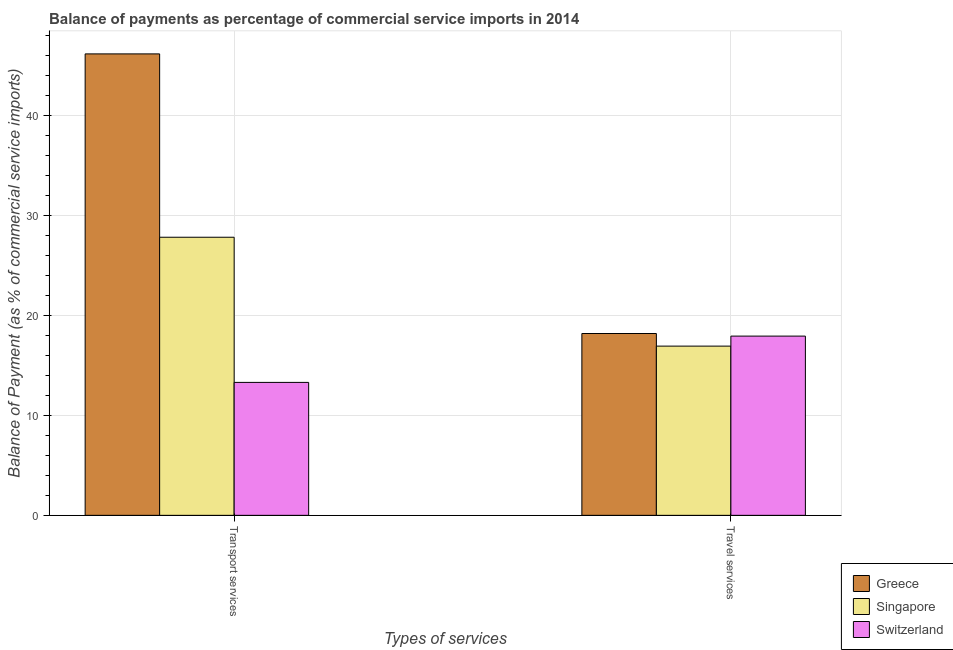How many different coloured bars are there?
Ensure brevity in your answer.  3. Are the number of bars on each tick of the X-axis equal?
Provide a short and direct response. Yes. How many bars are there on the 2nd tick from the left?
Offer a very short reply. 3. What is the label of the 2nd group of bars from the left?
Your answer should be compact. Travel services. What is the balance of payments of transport services in Singapore?
Keep it short and to the point. 27.83. Across all countries, what is the maximum balance of payments of transport services?
Provide a short and direct response. 46.17. Across all countries, what is the minimum balance of payments of travel services?
Ensure brevity in your answer.  16.93. In which country was the balance of payments of travel services maximum?
Keep it short and to the point. Greece. In which country was the balance of payments of travel services minimum?
Your response must be concise. Singapore. What is the total balance of payments of transport services in the graph?
Provide a succinct answer. 87.3. What is the difference between the balance of payments of travel services in Greece and that in Singapore?
Provide a short and direct response. 1.26. What is the difference between the balance of payments of travel services in Switzerland and the balance of payments of transport services in Greece?
Your answer should be very brief. -28.24. What is the average balance of payments of transport services per country?
Keep it short and to the point. 29.1. What is the difference between the balance of payments of transport services and balance of payments of travel services in Switzerland?
Your response must be concise. -4.63. What is the ratio of the balance of payments of travel services in Greece to that in Singapore?
Provide a short and direct response. 1.07. Is the balance of payments of transport services in Greece less than that in Switzerland?
Your response must be concise. No. What does the 2nd bar from the left in Transport services represents?
Your answer should be very brief. Singapore. What does the 2nd bar from the right in Travel services represents?
Provide a succinct answer. Singapore. How many bars are there?
Your answer should be compact. 6. Are the values on the major ticks of Y-axis written in scientific E-notation?
Provide a short and direct response. No. Does the graph contain any zero values?
Ensure brevity in your answer.  No. Does the graph contain grids?
Offer a terse response. Yes. How are the legend labels stacked?
Provide a succinct answer. Vertical. What is the title of the graph?
Provide a short and direct response. Balance of payments as percentage of commercial service imports in 2014. What is the label or title of the X-axis?
Make the answer very short. Types of services. What is the label or title of the Y-axis?
Offer a very short reply. Balance of Payment (as % of commercial service imports). What is the Balance of Payment (as % of commercial service imports) of Greece in Transport services?
Provide a succinct answer. 46.17. What is the Balance of Payment (as % of commercial service imports) in Singapore in Transport services?
Your response must be concise. 27.83. What is the Balance of Payment (as % of commercial service imports) of Switzerland in Transport services?
Your response must be concise. 13.3. What is the Balance of Payment (as % of commercial service imports) in Greece in Travel services?
Provide a short and direct response. 18.2. What is the Balance of Payment (as % of commercial service imports) in Singapore in Travel services?
Offer a terse response. 16.93. What is the Balance of Payment (as % of commercial service imports) of Switzerland in Travel services?
Provide a succinct answer. 17.94. Across all Types of services, what is the maximum Balance of Payment (as % of commercial service imports) in Greece?
Your answer should be compact. 46.17. Across all Types of services, what is the maximum Balance of Payment (as % of commercial service imports) of Singapore?
Give a very brief answer. 27.83. Across all Types of services, what is the maximum Balance of Payment (as % of commercial service imports) of Switzerland?
Provide a short and direct response. 17.94. Across all Types of services, what is the minimum Balance of Payment (as % of commercial service imports) of Greece?
Your answer should be very brief. 18.2. Across all Types of services, what is the minimum Balance of Payment (as % of commercial service imports) of Singapore?
Offer a very short reply. 16.93. Across all Types of services, what is the minimum Balance of Payment (as % of commercial service imports) of Switzerland?
Provide a succinct answer. 13.3. What is the total Balance of Payment (as % of commercial service imports) in Greece in the graph?
Offer a terse response. 64.37. What is the total Balance of Payment (as % of commercial service imports) in Singapore in the graph?
Give a very brief answer. 44.76. What is the total Balance of Payment (as % of commercial service imports) in Switzerland in the graph?
Your answer should be very brief. 31.24. What is the difference between the Balance of Payment (as % of commercial service imports) in Greece in Transport services and that in Travel services?
Ensure brevity in your answer.  27.98. What is the difference between the Balance of Payment (as % of commercial service imports) of Singapore in Transport services and that in Travel services?
Your answer should be very brief. 10.89. What is the difference between the Balance of Payment (as % of commercial service imports) of Switzerland in Transport services and that in Travel services?
Keep it short and to the point. -4.63. What is the difference between the Balance of Payment (as % of commercial service imports) in Greece in Transport services and the Balance of Payment (as % of commercial service imports) in Singapore in Travel services?
Offer a terse response. 29.24. What is the difference between the Balance of Payment (as % of commercial service imports) in Greece in Transport services and the Balance of Payment (as % of commercial service imports) in Switzerland in Travel services?
Give a very brief answer. 28.24. What is the difference between the Balance of Payment (as % of commercial service imports) of Singapore in Transport services and the Balance of Payment (as % of commercial service imports) of Switzerland in Travel services?
Keep it short and to the point. 9.89. What is the average Balance of Payment (as % of commercial service imports) in Greece per Types of services?
Your answer should be very brief. 32.18. What is the average Balance of Payment (as % of commercial service imports) of Singapore per Types of services?
Give a very brief answer. 22.38. What is the average Balance of Payment (as % of commercial service imports) of Switzerland per Types of services?
Keep it short and to the point. 15.62. What is the difference between the Balance of Payment (as % of commercial service imports) in Greece and Balance of Payment (as % of commercial service imports) in Singapore in Transport services?
Your answer should be very brief. 18.35. What is the difference between the Balance of Payment (as % of commercial service imports) of Greece and Balance of Payment (as % of commercial service imports) of Switzerland in Transport services?
Your response must be concise. 32.87. What is the difference between the Balance of Payment (as % of commercial service imports) of Singapore and Balance of Payment (as % of commercial service imports) of Switzerland in Transport services?
Offer a very short reply. 14.52. What is the difference between the Balance of Payment (as % of commercial service imports) of Greece and Balance of Payment (as % of commercial service imports) of Singapore in Travel services?
Your response must be concise. 1.26. What is the difference between the Balance of Payment (as % of commercial service imports) of Greece and Balance of Payment (as % of commercial service imports) of Switzerland in Travel services?
Your answer should be compact. 0.26. What is the difference between the Balance of Payment (as % of commercial service imports) of Singapore and Balance of Payment (as % of commercial service imports) of Switzerland in Travel services?
Your answer should be very brief. -1. What is the ratio of the Balance of Payment (as % of commercial service imports) of Greece in Transport services to that in Travel services?
Provide a short and direct response. 2.54. What is the ratio of the Balance of Payment (as % of commercial service imports) in Singapore in Transport services to that in Travel services?
Give a very brief answer. 1.64. What is the ratio of the Balance of Payment (as % of commercial service imports) of Switzerland in Transport services to that in Travel services?
Your answer should be very brief. 0.74. What is the difference between the highest and the second highest Balance of Payment (as % of commercial service imports) in Greece?
Your response must be concise. 27.98. What is the difference between the highest and the second highest Balance of Payment (as % of commercial service imports) of Singapore?
Ensure brevity in your answer.  10.89. What is the difference between the highest and the second highest Balance of Payment (as % of commercial service imports) of Switzerland?
Keep it short and to the point. 4.63. What is the difference between the highest and the lowest Balance of Payment (as % of commercial service imports) of Greece?
Provide a short and direct response. 27.98. What is the difference between the highest and the lowest Balance of Payment (as % of commercial service imports) in Singapore?
Offer a terse response. 10.89. What is the difference between the highest and the lowest Balance of Payment (as % of commercial service imports) in Switzerland?
Provide a succinct answer. 4.63. 